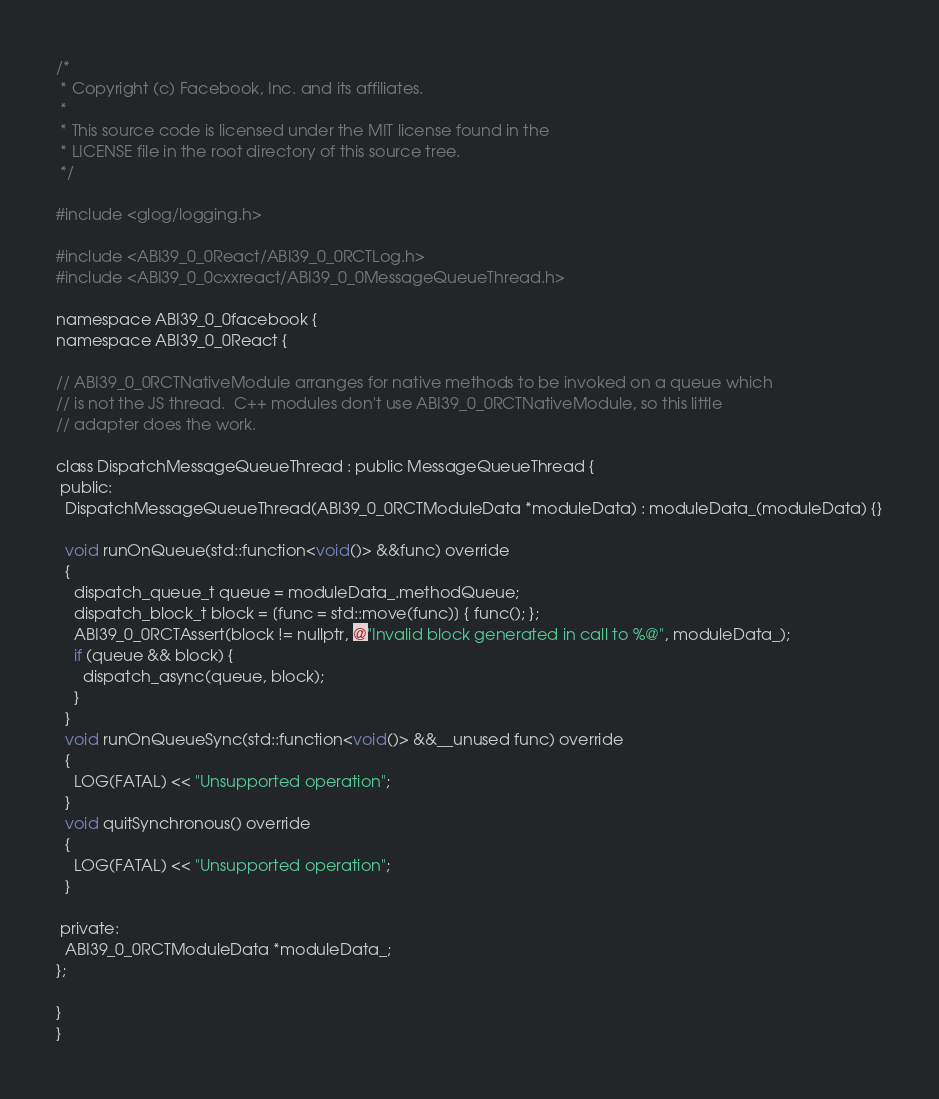Convert code to text. <code><loc_0><loc_0><loc_500><loc_500><_C_>/*
 * Copyright (c) Facebook, Inc. and its affiliates.
 *
 * This source code is licensed under the MIT license found in the
 * LICENSE file in the root directory of this source tree.
 */

#include <glog/logging.h>

#include <ABI39_0_0React/ABI39_0_0RCTLog.h>
#include <ABI39_0_0cxxreact/ABI39_0_0MessageQueueThread.h>

namespace ABI39_0_0facebook {
namespace ABI39_0_0React {

// ABI39_0_0RCTNativeModule arranges for native methods to be invoked on a queue which
// is not the JS thread.  C++ modules don't use ABI39_0_0RCTNativeModule, so this little
// adapter does the work.

class DispatchMessageQueueThread : public MessageQueueThread {
 public:
  DispatchMessageQueueThread(ABI39_0_0RCTModuleData *moduleData) : moduleData_(moduleData) {}

  void runOnQueue(std::function<void()> &&func) override
  {
    dispatch_queue_t queue = moduleData_.methodQueue;
    dispatch_block_t block = [func = std::move(func)] { func(); };
    ABI39_0_0RCTAssert(block != nullptr, @"Invalid block generated in call to %@", moduleData_);
    if (queue && block) {
      dispatch_async(queue, block);
    }
  }
  void runOnQueueSync(std::function<void()> &&__unused func) override
  {
    LOG(FATAL) << "Unsupported operation";
  }
  void quitSynchronous() override
  {
    LOG(FATAL) << "Unsupported operation";
  }

 private:
  ABI39_0_0RCTModuleData *moduleData_;
};

}
}
</code> 